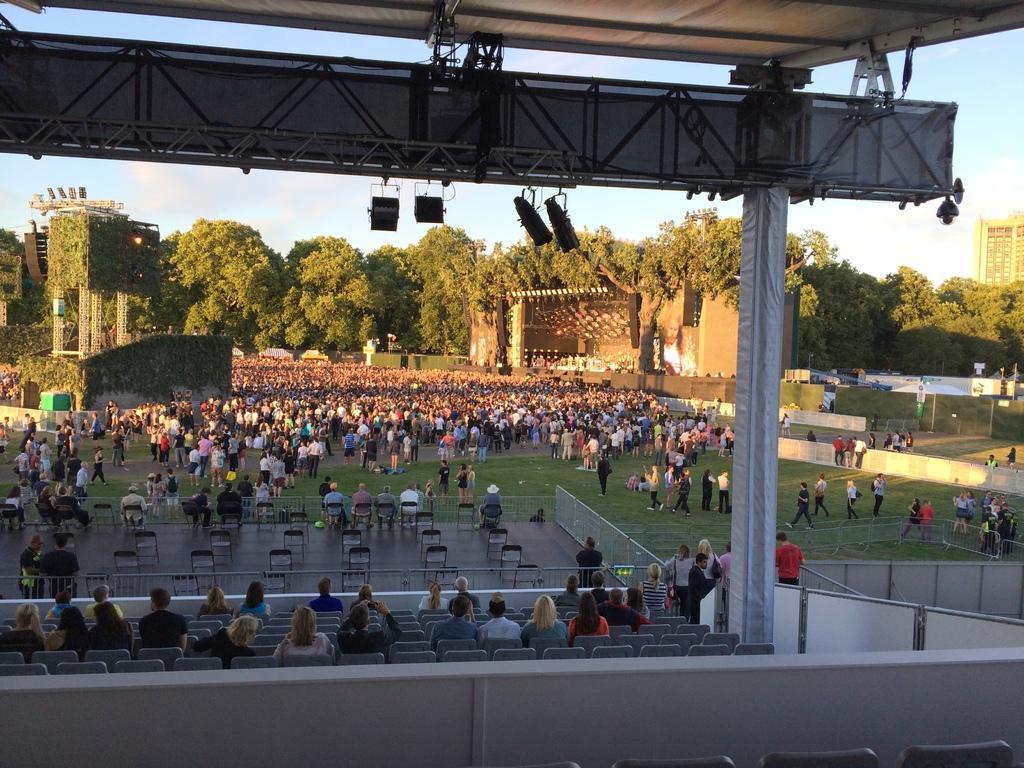Could you give a brief overview of what you see in this image? There are persons sitting on chairs. Above them, there is a roof which attached to the pillar. In the background, there are persons sitting on chairs, there are persons on the ground, there are trees, buildings and clouds in the blue sky. 